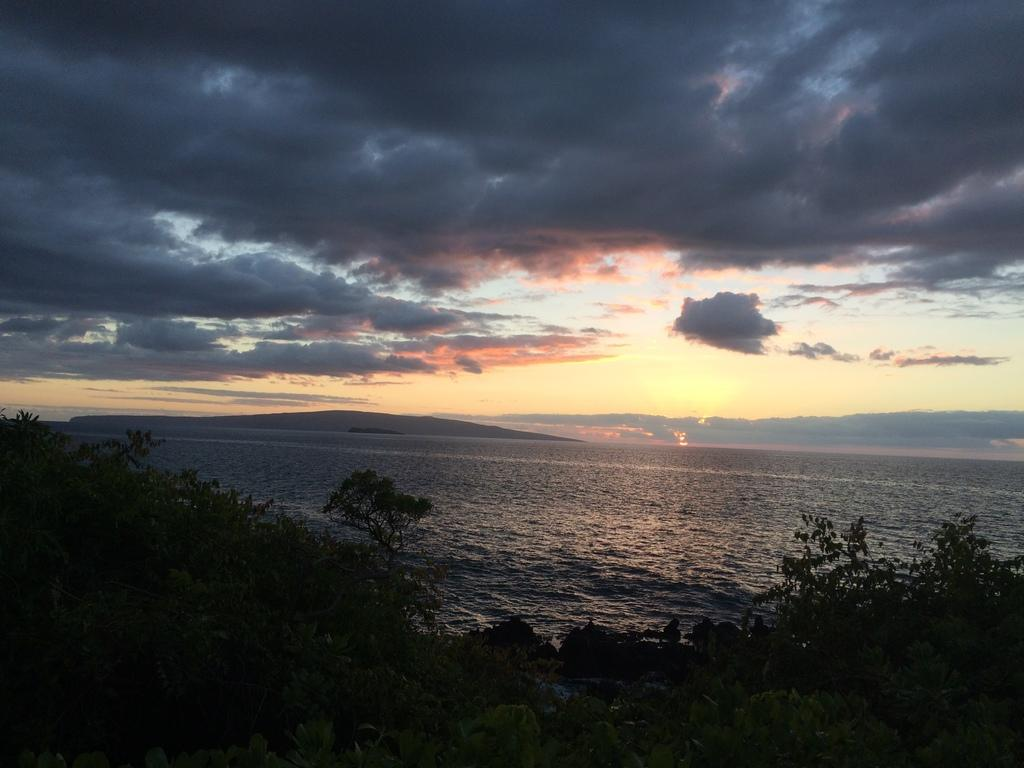What type of vegetation can be seen in the image? There are trees in the image. What natural element is visible besides the trees? There is water visible in the image. What is the condition of the sky in the image? The sky is cloudy in the image. What type of substance can be seen on the knee of the sheep in the image? There are no sheep present in the image, so it is not possible to answer that question. 